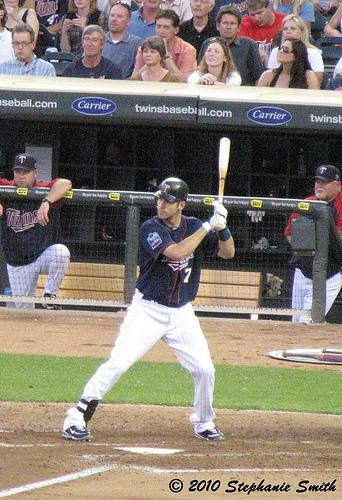Question: when will the player put down the bat?
Choices:
A. After he hits the baseball.
B. After his turn.
C. In five minutes.
D. Later today.
Answer with the letter. Answer: A Question: what is the player wearing on his head?
Choices:
A. A hat.
B. Sunglasses.
C. A visor.
D. A helmet.
Answer with the letter. Answer: D Question: where is this picture taken?
Choices:
A. Soccer field.
B. On a baseball field.
C. Football field.
D. In the kitchen.
Answer with the letter. Answer: B Question: why is the player holding the bat up?
Choices:
A. He is preparing to hit the baseball.
B. He is posing for the camera.
C. It is his turn to swing.
D. He wants to look tough.
Answer with the letter. Answer: A Question: who is standing in this picture?
Choices:
A. Men.
B. The team.
C. The workers.
D. The children.
Answer with the letter. Answer: A 